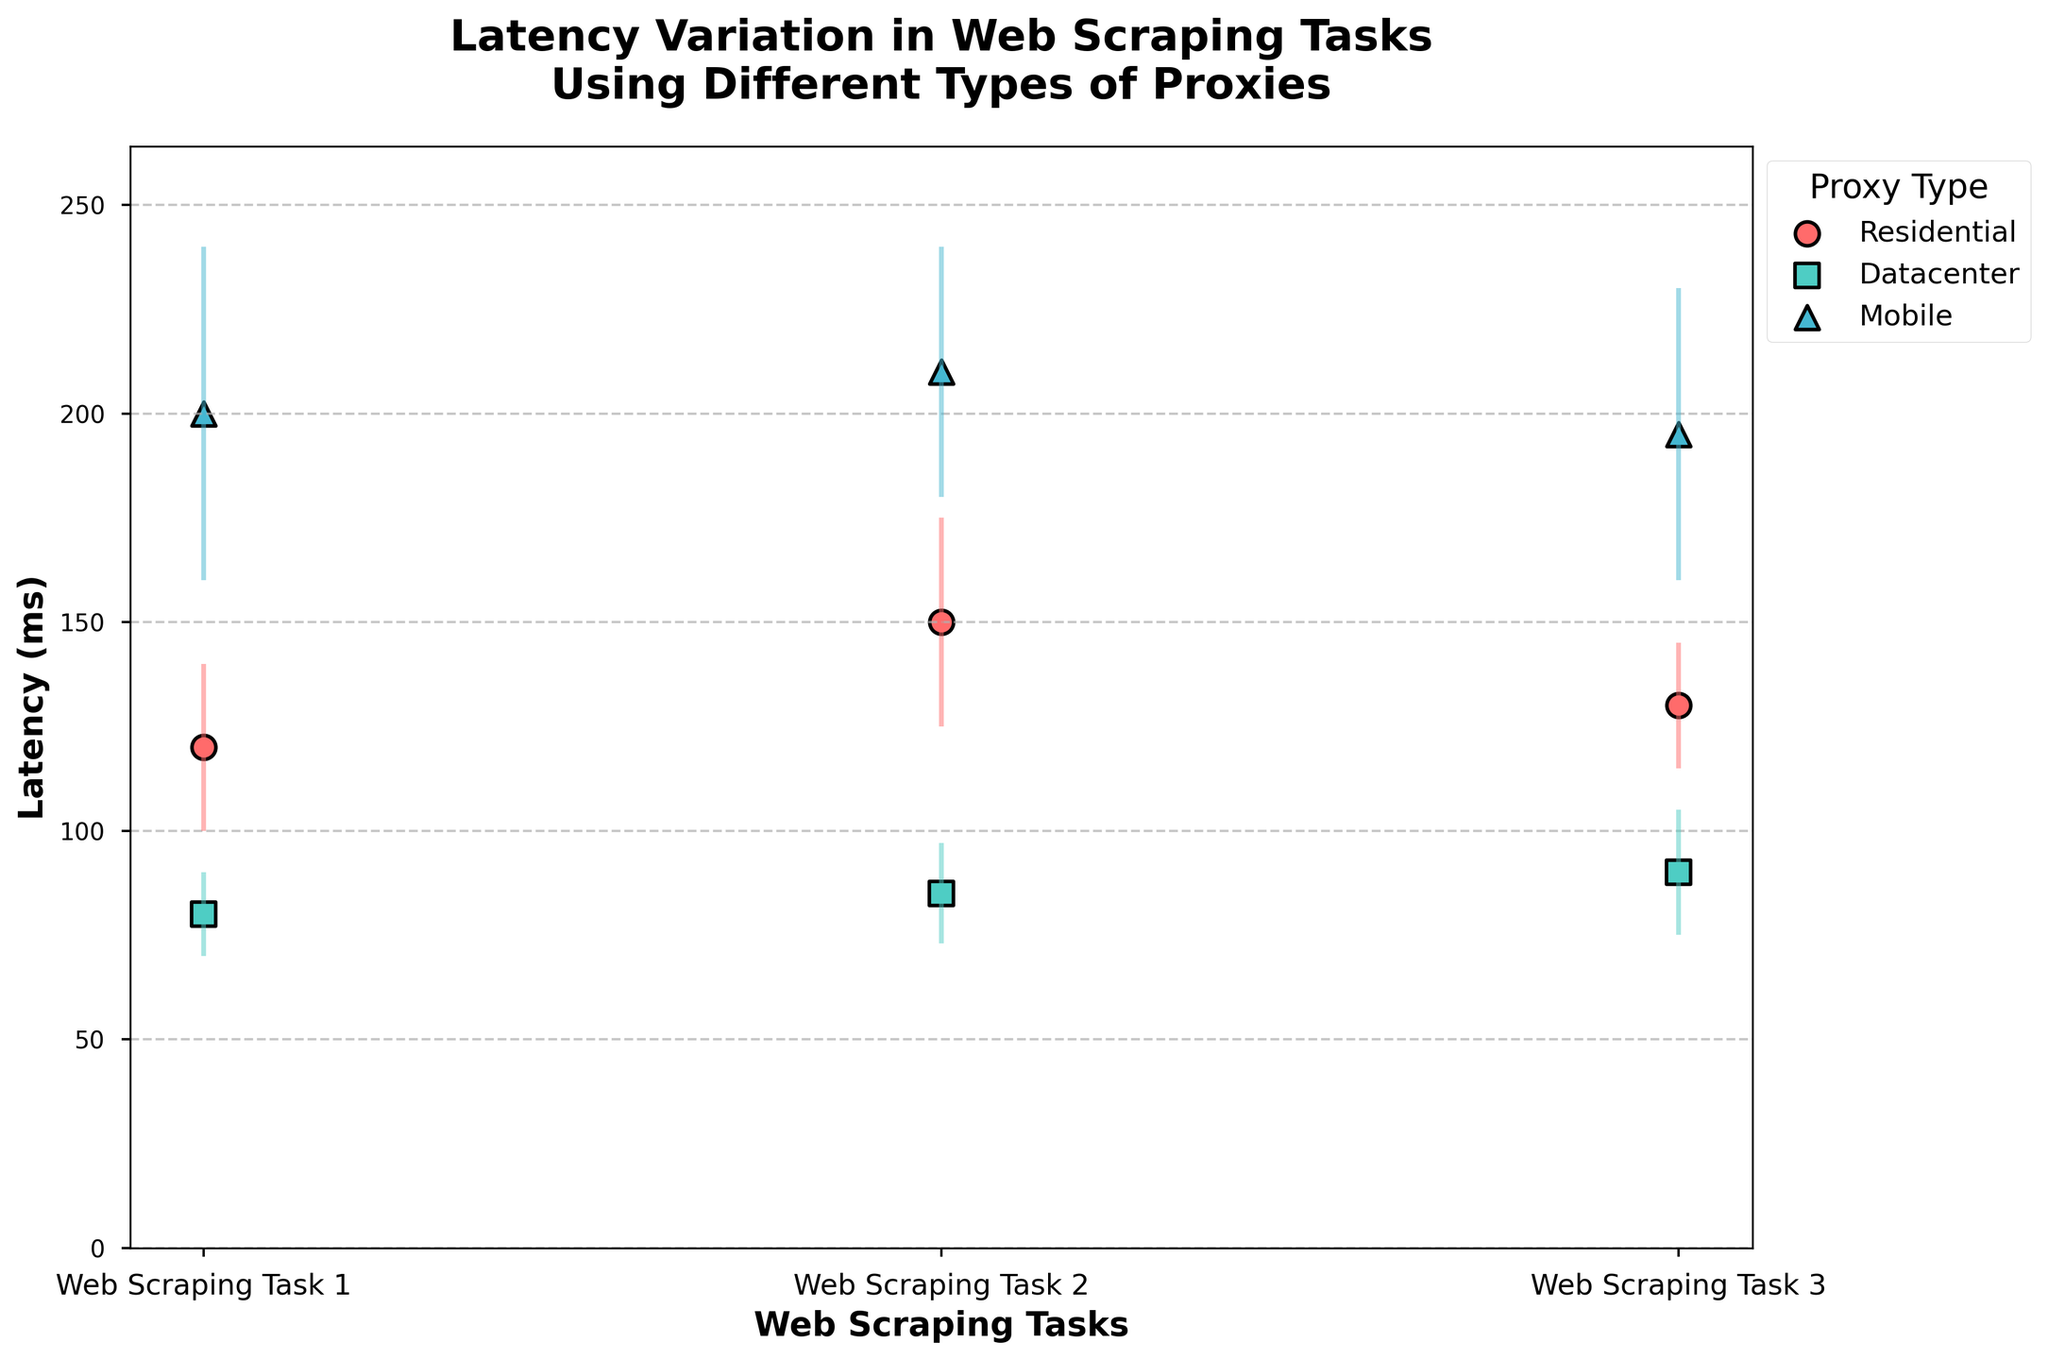What is the title of the figure? The title is usually displayed at the top of the figure in bold. In this case, it reads "Latency Variation in Web Scraping Tasks Using Different Types of Proxies".
Answer: Latency Variation in Web Scraping Tasks Using Different Types of Proxies What do the x-axis labels represent? The x-axis labels usually indicate the categories or steps in the dataset. Here, they represent different web scraping tasks labeled as "Web Scraping Task 1", "Web Scraping Task 2", and "Web Scraping Task 3".
Answer: Web Scraping Tasks Which proxy type has the highest average latency for Web Scraping Task 1? To determine this, look at the scatter points for Web Scraping Task 1 and compare their average latencies. The highest point corresponds to the Mobile proxy type with a latency of 200 ms.
Answer: Mobile Which proxy type shows the most variance in latency for Web Scraping Task 2? Variance can be inferred from error bars. The proxy type with the longest error bars in Web Scraping Task 2 is the Mobile proxy type with a variance of ±30 ms.
Answer: Mobile What is the latency mean for the Datacenter proxy in Web Scraping Task 3? Find the scatter point that represents the Datacenter proxy type in Web Scraping Task 3. The latency mean is shown as 90 ms.
Answer: 90 ms Which proxy type has the smallest latency in Web Scraping Task 2? Compare the heights of the scatter points for Web Scraping Task 2. The smallest latency corresponds to the Datacenter proxy type with a latency of 85 ms.
Answer: Datacenter What is the range of latencies for Residential proxies in Web Scraping Task 2? The range can be calculated by adding the standard deviation to the mean and subtracting it from the mean for both sides (150 ± 25 ms). This gives a range of 125 ms to 175 ms.
Answer: 125-175 ms How does the latency of Mobile proxies in Web Scraping Task 1 compare to Datacenter proxies in Web Scraping Task 1? Look at the scatter points for both proxy types in Web Scraping Task 1. Mobile proxies have a latency of 200 ms, and Datacenter proxies have a latency of 80 ms. Mobile proxies are significantly higher.
Answer: Mobile proxies are significantly higher Which task shows the greatest latency variation for Residential proxies? Check the lengths of the error bars for the Residential proxy type in each of the tasks. Web Scraping Task 2 shows the largest error bars indicating the greatest variation (±25 ms).
Answer: Web Scraping Task 2 How many types of proxies are represented in the figure? Count the unique labels/colors used in the legend that represent different proxy types. There are three: Residential, Datacenter, and Mobile.
Answer: Three 